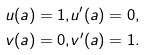<formula> <loc_0><loc_0><loc_500><loc_500>u ( a ) = 1 , & u ^ { \prime } ( a ) = 0 , \\ v ( a ) = 0 , & v ^ { \prime } ( a ) = 1 .</formula> 